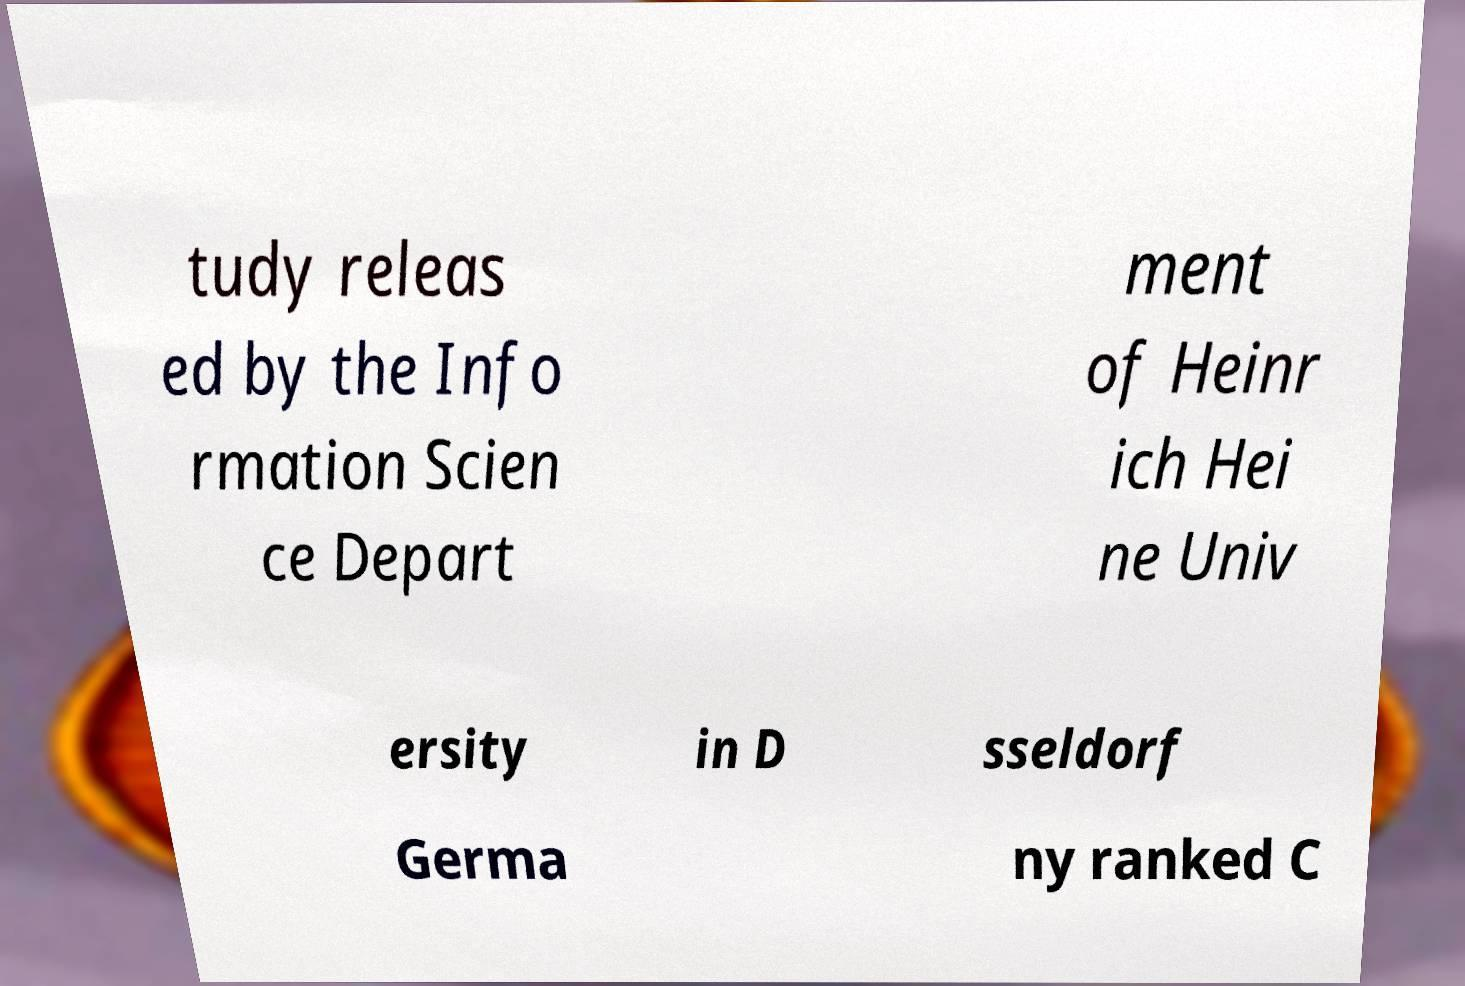Could you extract and type out the text from this image? tudy releas ed by the Info rmation Scien ce Depart ment of Heinr ich Hei ne Univ ersity in D sseldorf Germa ny ranked C 